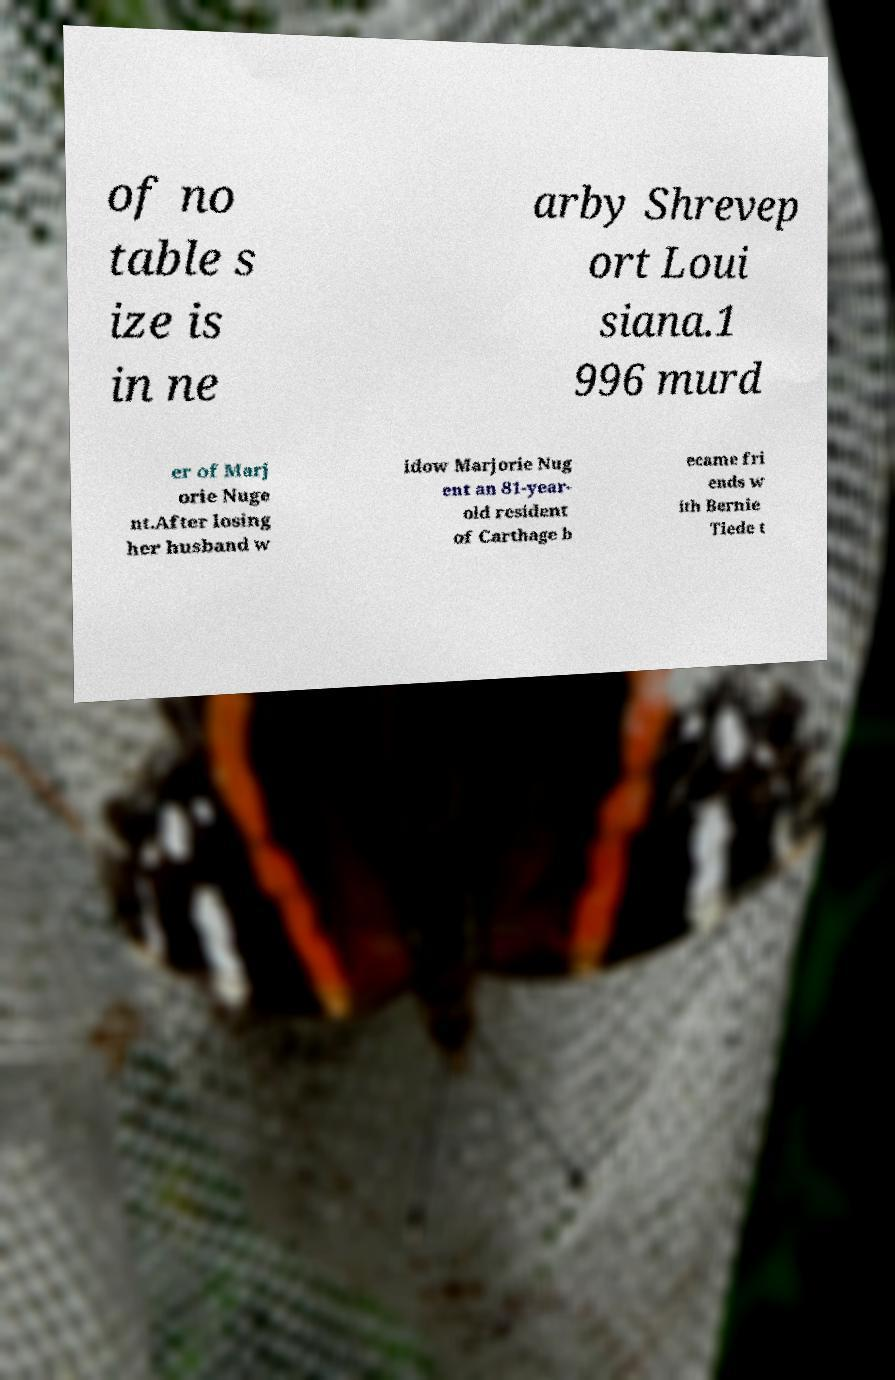Can you accurately transcribe the text from the provided image for me? of no table s ize is in ne arby Shrevep ort Loui siana.1 996 murd er of Marj orie Nuge nt.After losing her husband w idow Marjorie Nug ent an 81-year- old resident of Carthage b ecame fri ends w ith Bernie Tiede t 